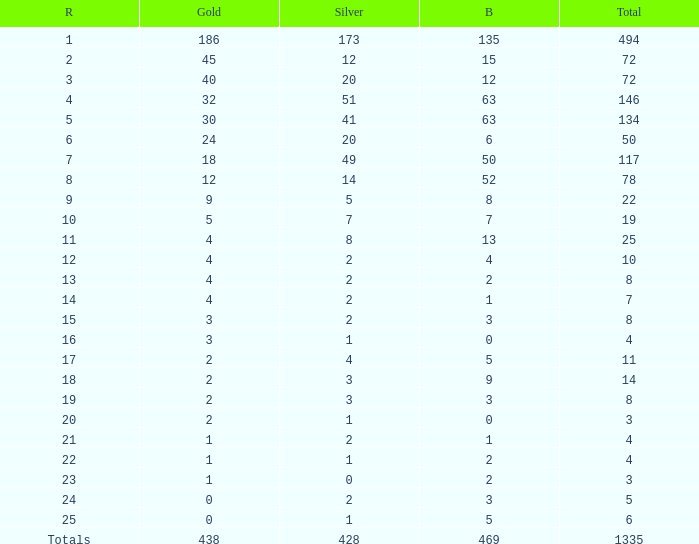What is the average number of gold medals when the total was 1335 medals, with more than 469 bronzes and more than 14 silvers? None. 